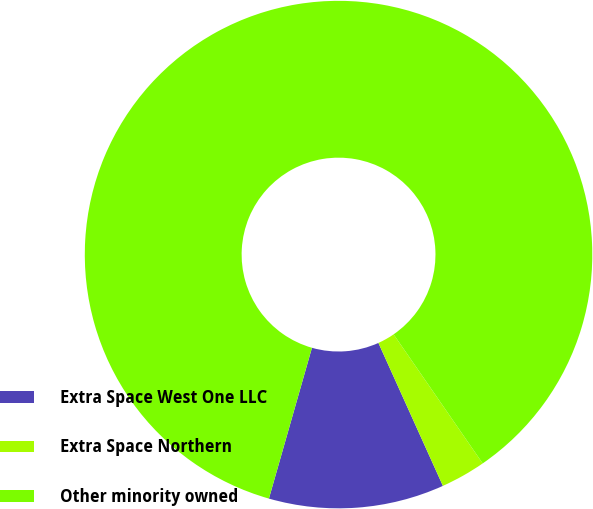Convert chart to OTSL. <chart><loc_0><loc_0><loc_500><loc_500><pie_chart><fcel>Extra Space West One LLC<fcel>Extra Space Northern<fcel>Other minority owned<nl><fcel>11.17%<fcel>2.87%<fcel>85.96%<nl></chart> 